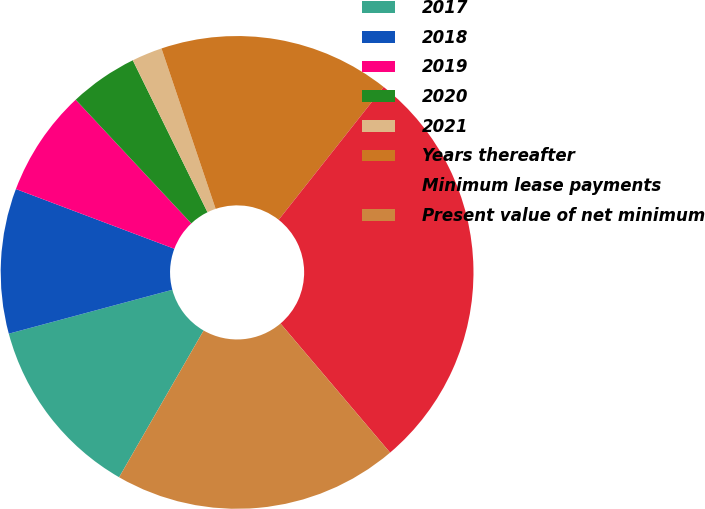<chart> <loc_0><loc_0><loc_500><loc_500><pie_chart><fcel>2017<fcel>2018<fcel>2019<fcel>2020<fcel>2021<fcel>Years thereafter<fcel>Minimum lease payments<fcel>Present value of net minimum<nl><fcel>12.51%<fcel>9.91%<fcel>7.3%<fcel>4.69%<fcel>2.09%<fcel>15.83%<fcel>28.15%<fcel>19.52%<nl></chart> 